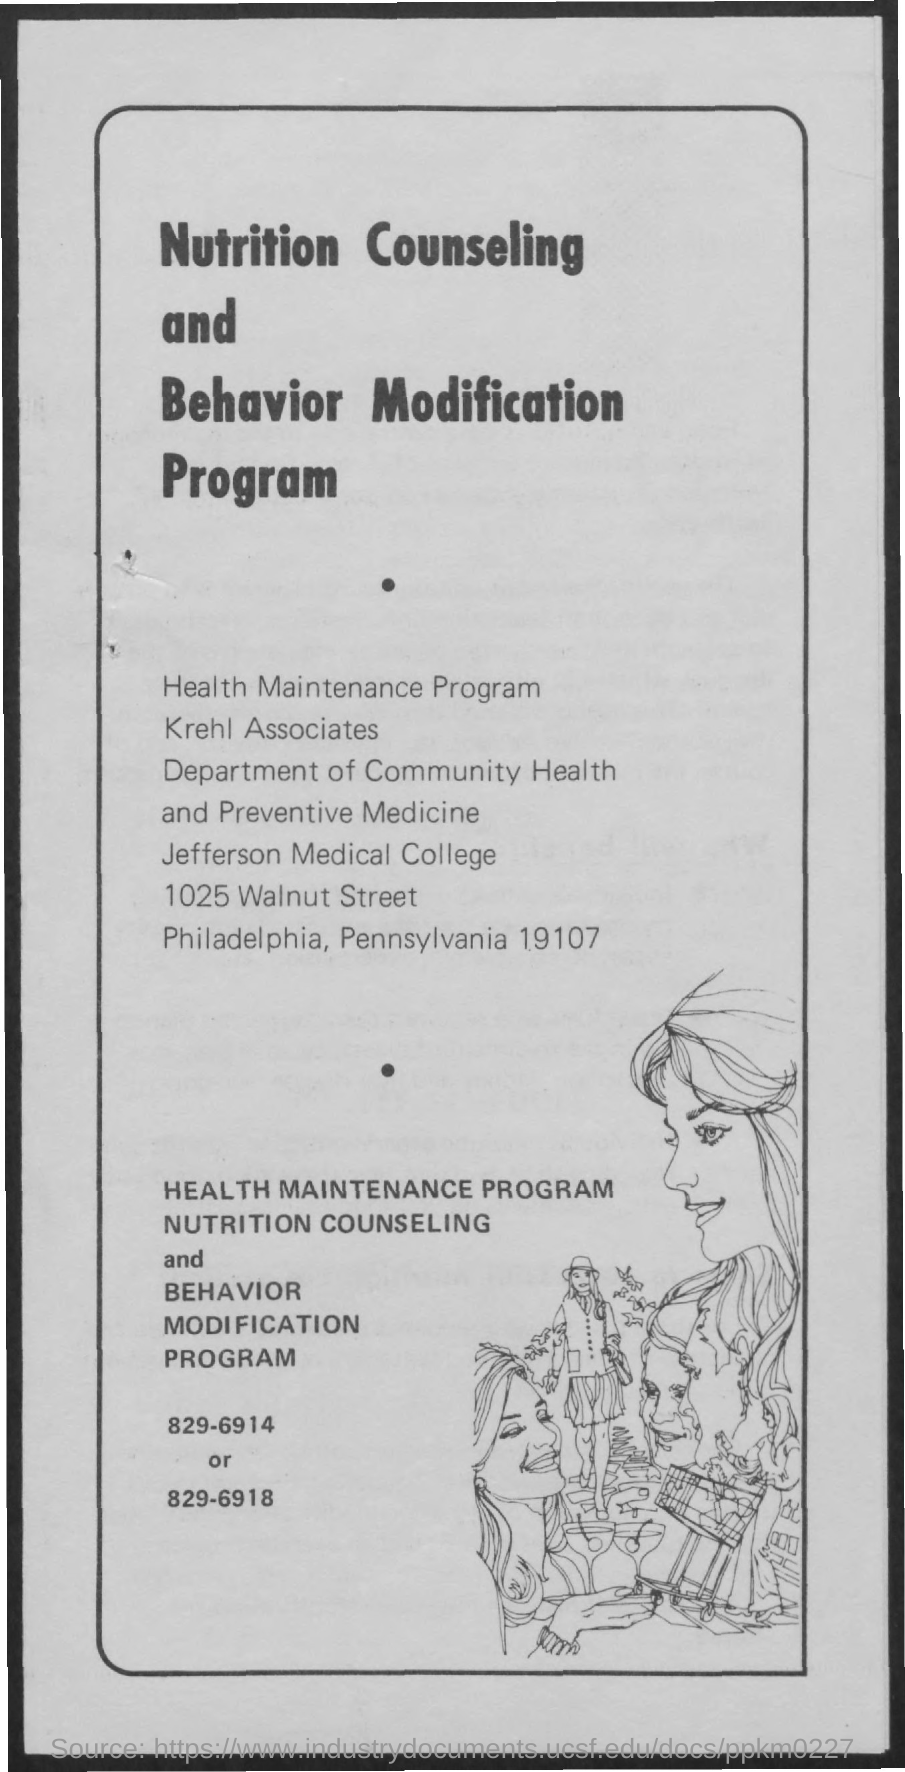What is the name of the department mentioned in the given page ?
Offer a terse response. DEPARTMENT OF COMMUNITY HEALTH AND PREVENTIVE MEDICINE. What is the name of the college given in the page ?
Your answer should be compact. JEFFERSON MEDICAL COLLEGE. 